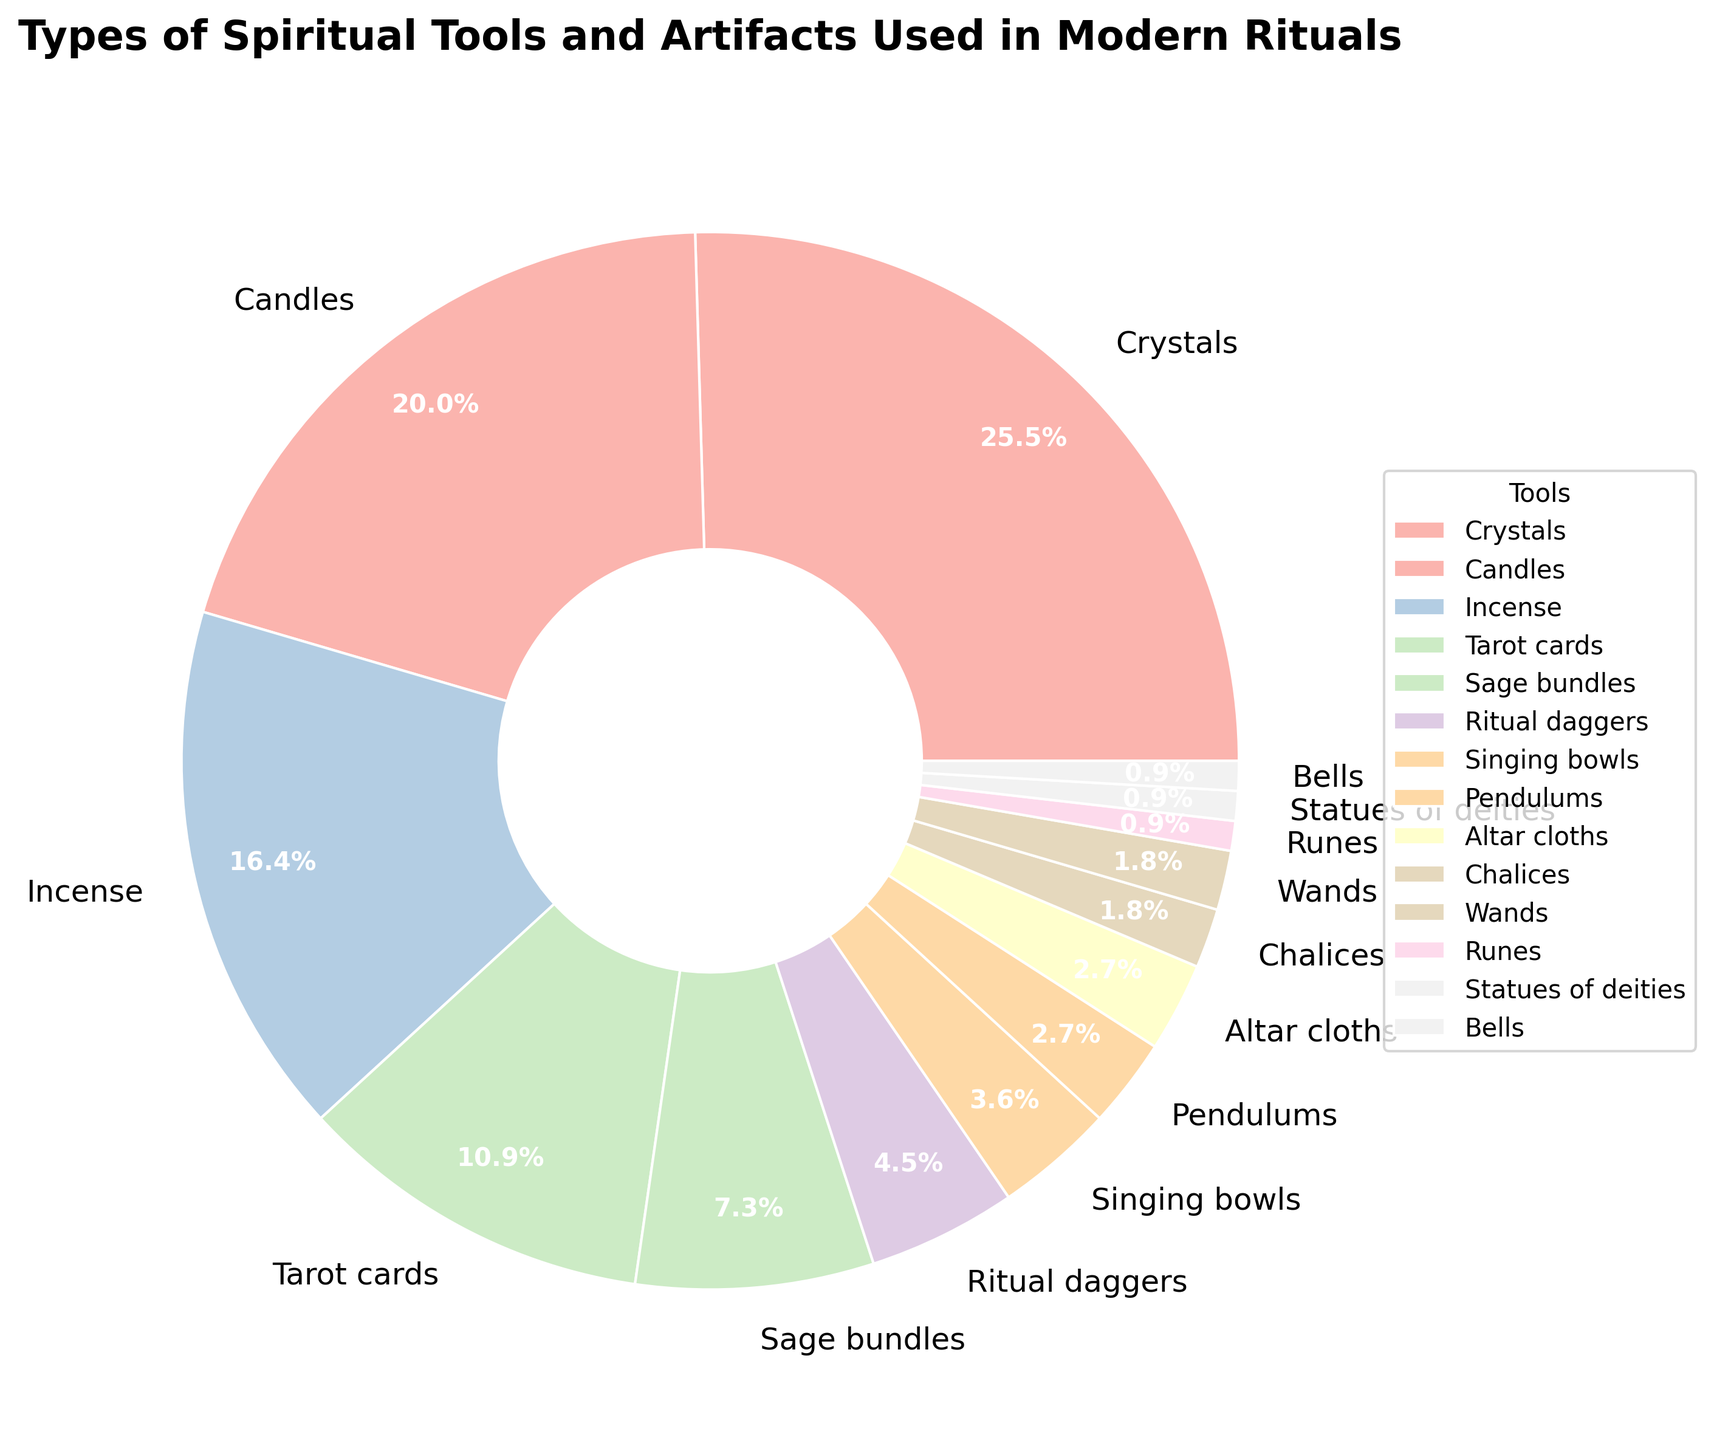Which spiritual tool has the highest frequency in modern rituals? The figure shows that "Crystals" has the largest section of the pie chart. It is the most frequent tool.
Answer: Crystals What is the combined frequency of Candles and Incense? Adding the frequencies of Candles (22) and Incense (18) gives 40.
Answer: 40 How many more times are Sage Bundles used compared to Chalices in rituals? Sage Bundles have a frequency of 8, and Chalices have 2. The difference is 8 - 2 = 6.
Answer: 6 Which tool appears exactly twice in the pie chart? The pie chart shows that both Chalices and Wands each have a frequency of 2.
Answer: Chalices, Wands Are Tarot Cards used more or less frequently than Sage Bundles? Comparing the sections, Tarot Cards (12) are used more frequently than Sage Bundles (8).
Answer: More frequently Which tools are the least commonly used in rituals? The pie chart shows Runes, Statues of Deities, and Bells, each with a frequency of 1.
Answer: Runes, Statues of Deities, Bells What percentage of the total does the use of Singing Bowls represent? Singing Bowls have a frequency of 4. The total frequency is 110. The percentage is (4/110) * 100 = 3.64%.
Answer: 3.64% How does the combined usage of Pendulums and Altar Cloths compare to Ritual Daggers? Pendulums (3) + Altar Cloths (3) = 6, which is more than Ritual Daggers (5).
Answer: More Which tools have frequencies that are equal? The pie chart shows that Altar Cloths and Pendulums each have a frequency of 3.
Answer: Altar Cloths, Pendulums If the frequencies of Crystals and Candles were doubled, what would their new total frequency be? The current frequencies are Crystals (28) and Candles (22). Doubling them gives 2*28 + 2*22 = 56 + 44 = 100.
Answer: 100 